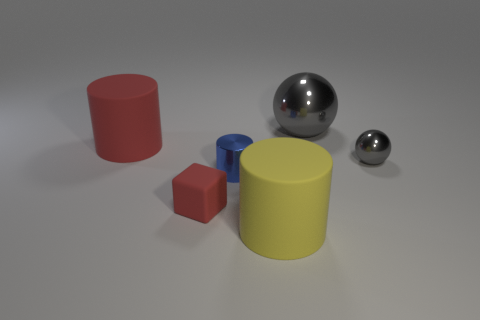Add 3 tiny gray metal spheres. How many objects exist? 9 Subtract all large cylinders. How many cylinders are left? 1 Subtract all yellow cylinders. How many cylinders are left? 2 Subtract 2 balls. How many balls are left? 0 Add 3 small gray objects. How many small gray objects exist? 4 Subtract 0 brown cubes. How many objects are left? 6 Subtract all balls. How many objects are left? 4 Subtract all yellow cylinders. Subtract all purple cubes. How many cylinders are left? 2 Subtract all red spheres. How many red cylinders are left? 1 Subtract all large balls. Subtract all large rubber cylinders. How many objects are left? 3 